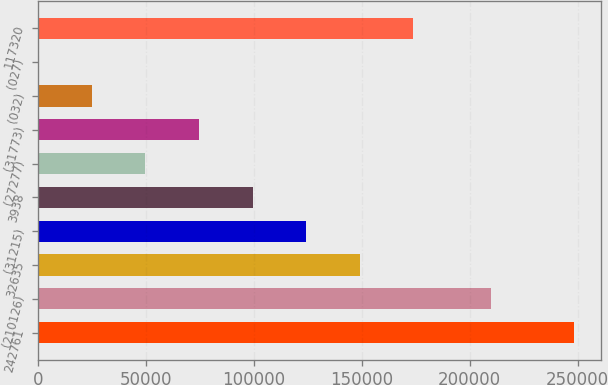Convert chart. <chart><loc_0><loc_0><loc_500><loc_500><bar_chart><fcel>242761<fcel>(210126)<fcel>32635<fcel>(31215)<fcel>3938<fcel>(27277)<fcel>(31773)<fcel>(032)<fcel>(027)<fcel>117320<nl><fcel>248452<fcel>209822<fcel>149071<fcel>124226<fcel>99380.9<fcel>49690.6<fcel>74535.7<fcel>24845.4<fcel>0.19<fcel>173916<nl></chart> 